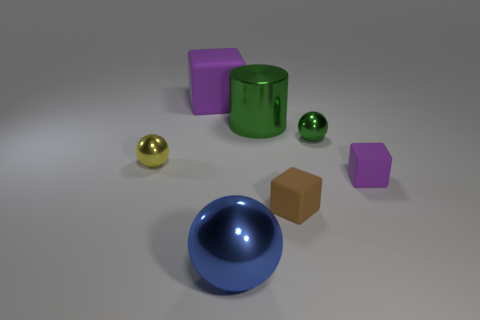What shape is the brown thing that is in front of the small yellow metal ball left of the purple rubber block that is behind the large green cylinder? The brown object in front of the small yellow metal ball, which is to the left of the purple rubber block that is positioned behind the large green cylinder, is indeed shaped like a cube. 